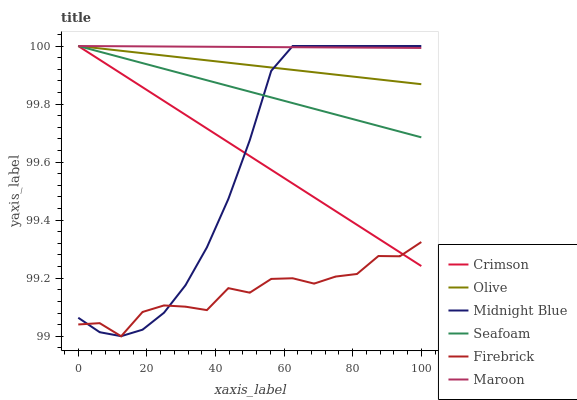Does Firebrick have the minimum area under the curve?
Answer yes or no. Yes. Does Maroon have the maximum area under the curve?
Answer yes or no. Yes. Does Seafoam have the minimum area under the curve?
Answer yes or no. No. Does Seafoam have the maximum area under the curve?
Answer yes or no. No. Is Crimson the smoothest?
Answer yes or no. Yes. Is Firebrick the roughest?
Answer yes or no. Yes. Is Seafoam the smoothest?
Answer yes or no. No. Is Seafoam the roughest?
Answer yes or no. No. Does Seafoam have the lowest value?
Answer yes or no. No. Does Crimson have the highest value?
Answer yes or no. Yes. Does Firebrick have the highest value?
Answer yes or no. No. Is Firebrick less than Seafoam?
Answer yes or no. Yes. Is Maroon greater than Firebrick?
Answer yes or no. Yes. Does Maroon intersect Midnight Blue?
Answer yes or no. Yes. Is Maroon less than Midnight Blue?
Answer yes or no. No. Is Maroon greater than Midnight Blue?
Answer yes or no. No. Does Firebrick intersect Seafoam?
Answer yes or no. No. 